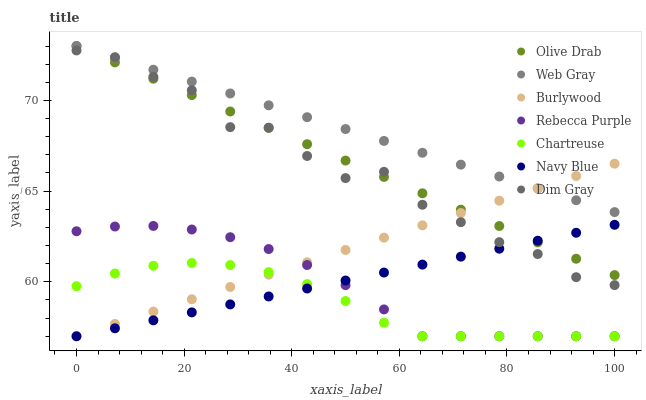Does Chartreuse have the minimum area under the curve?
Answer yes or no. Yes. Does Web Gray have the maximum area under the curve?
Answer yes or no. Yes. Does Burlywood have the minimum area under the curve?
Answer yes or no. No. Does Burlywood have the maximum area under the curve?
Answer yes or no. No. Is Burlywood the smoothest?
Answer yes or no. Yes. Is Dim Gray the roughest?
Answer yes or no. Yes. Is Navy Blue the smoothest?
Answer yes or no. No. Is Navy Blue the roughest?
Answer yes or no. No. Does Burlywood have the lowest value?
Answer yes or no. Yes. Does Dim Gray have the lowest value?
Answer yes or no. No. Does Olive Drab have the highest value?
Answer yes or no. Yes. Does Burlywood have the highest value?
Answer yes or no. No. Is Navy Blue less than Web Gray?
Answer yes or no. Yes. Is Olive Drab greater than Rebecca Purple?
Answer yes or no. Yes. Does Navy Blue intersect Burlywood?
Answer yes or no. Yes. Is Navy Blue less than Burlywood?
Answer yes or no. No. Is Navy Blue greater than Burlywood?
Answer yes or no. No. Does Navy Blue intersect Web Gray?
Answer yes or no. No. 